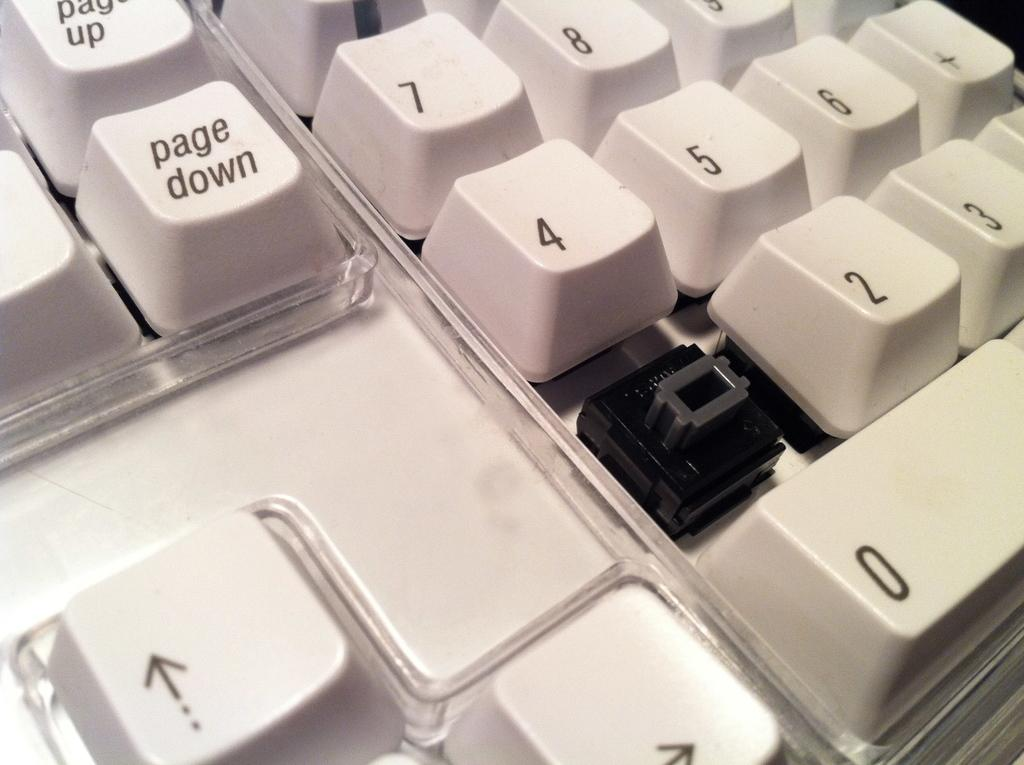Provide a one-sentence caption for the provided image. A closeup of a white keyboard with a key missing under the key labelled 4. 